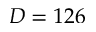Convert formula to latex. <formula><loc_0><loc_0><loc_500><loc_500>D = 1 2 6</formula> 